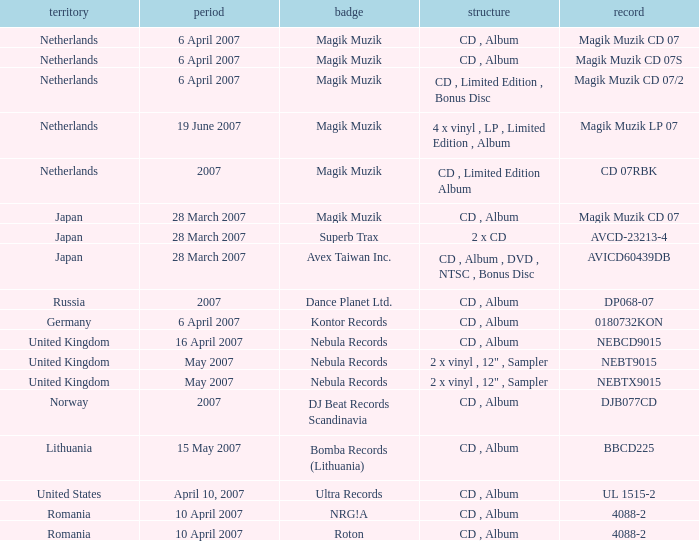Which label released the catalog Magik Muzik CD 07 on 28 March 2007? Magik Muzik. 